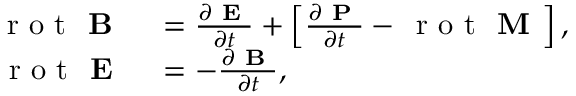Convert formula to latex. <formula><loc_0><loc_0><loc_500><loc_500>\begin{array} { r l } { \, r o t B } & = \frac { \partial E } { \partial t } + \left [ \frac { \partial P } { \partial t } - \, r o t M \right ] , } \\ { \, r o t E } & = - \frac { \partial B } { \partial t } , } \end{array}</formula> 